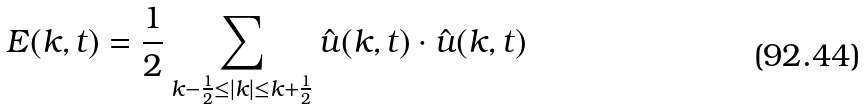Convert formula to latex. <formula><loc_0><loc_0><loc_500><loc_500>E ( k , t ) & = \frac { 1 } { 2 } \sum _ { k - \frac { 1 } { 2 } \leq | k | \leq k + \frac { 1 } { 2 } } \hat { u } ( k , t ) \cdot \hat { u } ( k , t )</formula> 